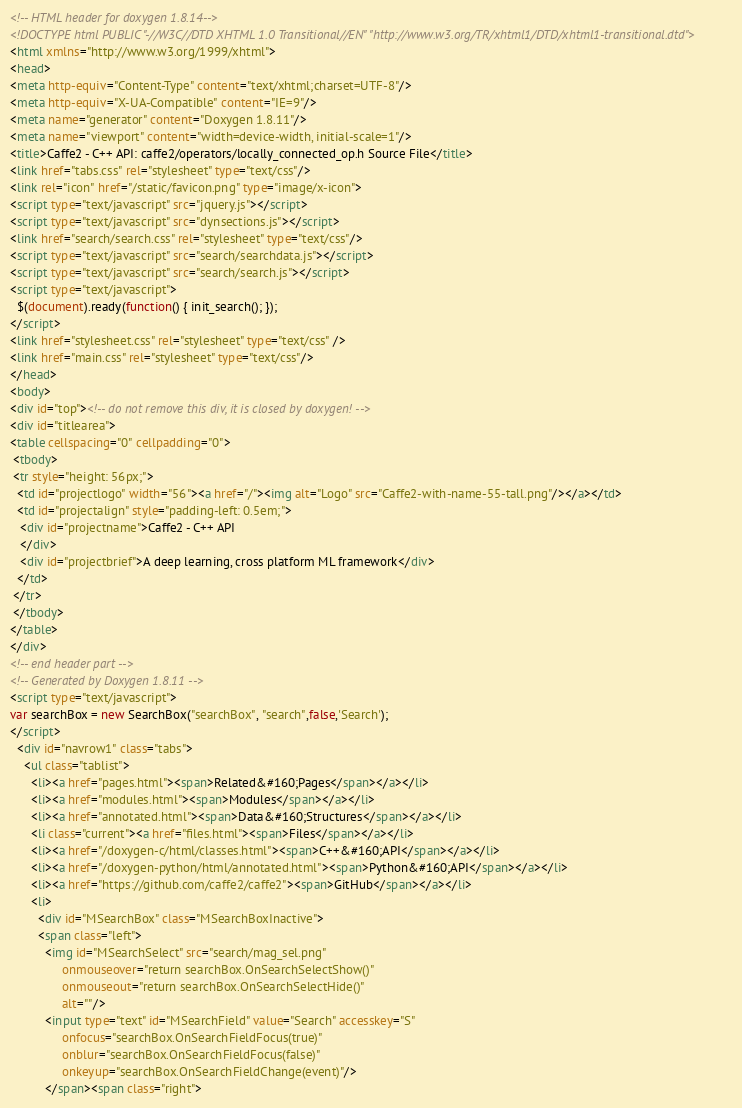<code> <loc_0><loc_0><loc_500><loc_500><_HTML_><!-- HTML header for doxygen 1.8.14-->
<!DOCTYPE html PUBLIC "-//W3C//DTD XHTML 1.0 Transitional//EN" "http://www.w3.org/TR/xhtml1/DTD/xhtml1-transitional.dtd">
<html xmlns="http://www.w3.org/1999/xhtml">
<head>
<meta http-equiv="Content-Type" content="text/xhtml;charset=UTF-8"/>
<meta http-equiv="X-UA-Compatible" content="IE=9"/>
<meta name="generator" content="Doxygen 1.8.11"/>
<meta name="viewport" content="width=device-width, initial-scale=1"/>
<title>Caffe2 - C++ API: caffe2/operators/locally_connected_op.h Source File</title>
<link href="tabs.css" rel="stylesheet" type="text/css"/>
<link rel="icon" href="/static/favicon.png" type="image/x-icon">
<script type="text/javascript" src="jquery.js"></script>
<script type="text/javascript" src="dynsections.js"></script>
<link href="search/search.css" rel="stylesheet" type="text/css"/>
<script type="text/javascript" src="search/searchdata.js"></script>
<script type="text/javascript" src="search/search.js"></script>
<script type="text/javascript">
  $(document).ready(function() { init_search(); });
</script>
<link href="stylesheet.css" rel="stylesheet" type="text/css" />
<link href="main.css" rel="stylesheet" type="text/css"/>
</head>
<body>
<div id="top"><!-- do not remove this div, it is closed by doxygen! -->
<div id="titlearea">
<table cellspacing="0" cellpadding="0">
 <tbody>
 <tr style="height: 56px;">
  <td id="projectlogo" width="56"><a href="/"><img alt="Logo" src="Caffe2-with-name-55-tall.png"/></a></td>
  <td id="projectalign" style="padding-left: 0.5em;">
   <div id="projectname">Caffe2 - C++ API
   </div>
   <div id="projectbrief">A deep learning, cross platform ML framework</div>
  </td>
 </tr>
 </tbody>
</table>
</div>
<!-- end header part -->
<!-- Generated by Doxygen 1.8.11 -->
<script type="text/javascript">
var searchBox = new SearchBox("searchBox", "search",false,'Search');
</script>
  <div id="navrow1" class="tabs">
    <ul class="tablist">
      <li><a href="pages.html"><span>Related&#160;Pages</span></a></li>
      <li><a href="modules.html"><span>Modules</span></a></li>
      <li><a href="annotated.html"><span>Data&#160;Structures</span></a></li>
      <li class="current"><a href="files.html"><span>Files</span></a></li>
      <li><a href="/doxygen-c/html/classes.html"><span>C++&#160;API</span></a></li>
      <li><a href="/doxygen-python/html/annotated.html"><span>Python&#160;API</span></a></li>
      <li><a href="https://github.com/caffe2/caffe2"><span>GitHub</span></a></li>
      <li>
        <div id="MSearchBox" class="MSearchBoxInactive">
        <span class="left">
          <img id="MSearchSelect" src="search/mag_sel.png"
               onmouseover="return searchBox.OnSearchSelectShow()"
               onmouseout="return searchBox.OnSearchSelectHide()"
               alt=""/>
          <input type="text" id="MSearchField" value="Search" accesskey="S"
               onfocus="searchBox.OnSearchFieldFocus(true)" 
               onblur="searchBox.OnSearchFieldFocus(false)" 
               onkeyup="searchBox.OnSearchFieldChange(event)"/>
          </span><span class="right"></code> 